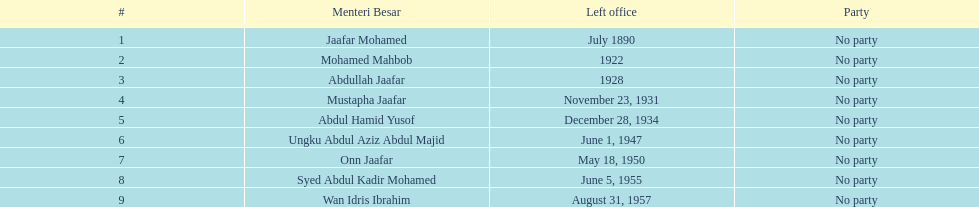Who was in office previous to abdullah jaafar? Mohamed Mahbob. 